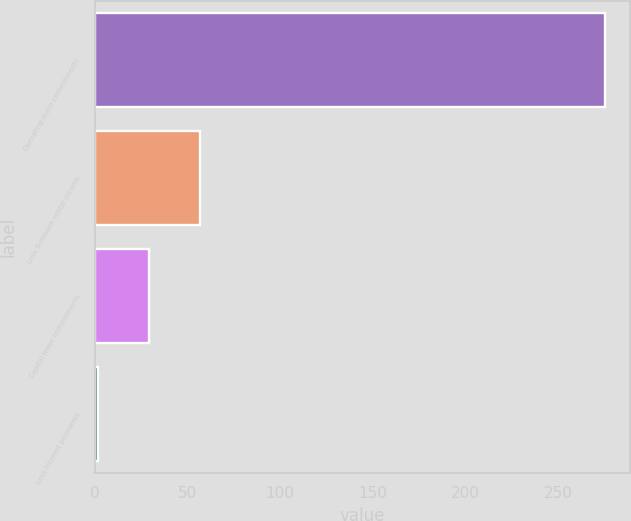<chart> <loc_0><loc_0><loc_500><loc_500><bar_chart><fcel>Operating lease commitments<fcel>Less Sublease rental income<fcel>Capital lease commitments<fcel>Less Interest payments<nl><fcel>275<fcel>56.6<fcel>29.3<fcel>2<nl></chart> 